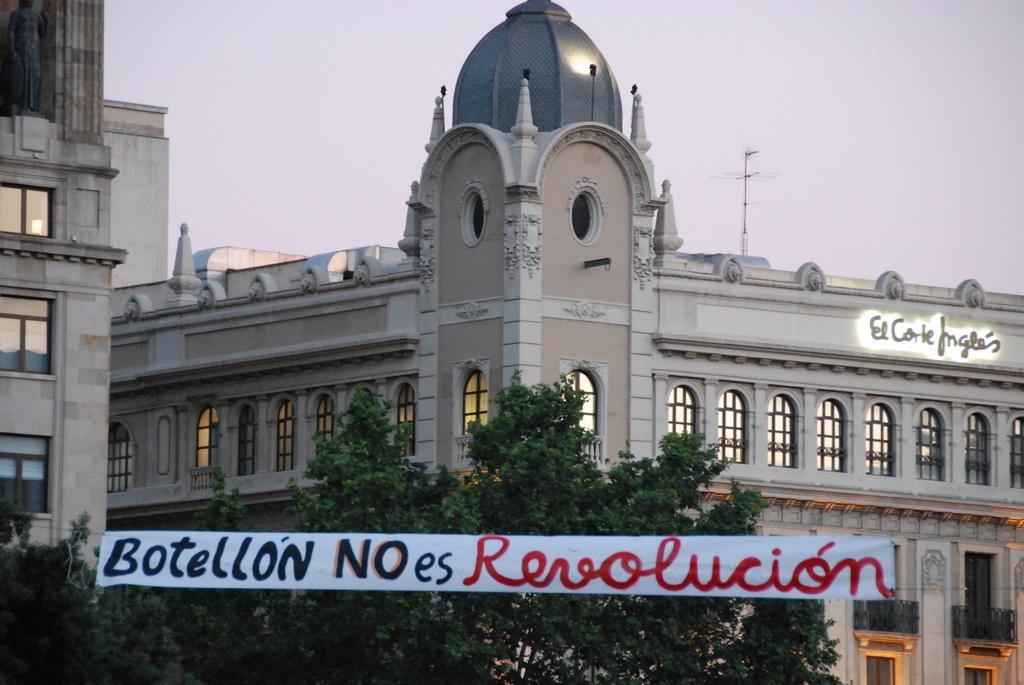What is located in the center of the image? There are buildings in the center of the image. What is at the bottom of the image? There is a banner and trees at the bottom of the image. What can be seen in the background of the image? The sky is visible in the background of the image. What type of amusement can be seen in the image? There is no amusement present in the image; it features buildings, a banner, trees, and the sky. What part of the human body is visible in the image? There are no human body parts visible in the image. 